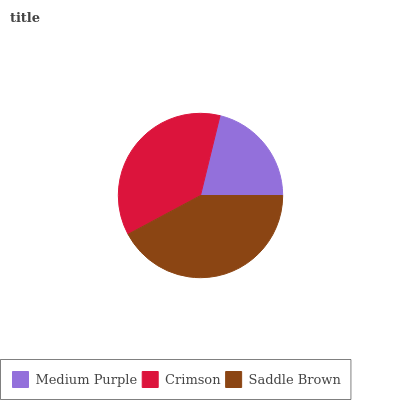Is Medium Purple the minimum?
Answer yes or no. Yes. Is Saddle Brown the maximum?
Answer yes or no. Yes. Is Crimson the minimum?
Answer yes or no. No. Is Crimson the maximum?
Answer yes or no. No. Is Crimson greater than Medium Purple?
Answer yes or no. Yes. Is Medium Purple less than Crimson?
Answer yes or no. Yes. Is Medium Purple greater than Crimson?
Answer yes or no. No. Is Crimson less than Medium Purple?
Answer yes or no. No. Is Crimson the high median?
Answer yes or no. Yes. Is Crimson the low median?
Answer yes or no. Yes. Is Saddle Brown the high median?
Answer yes or no. No. Is Saddle Brown the low median?
Answer yes or no. No. 